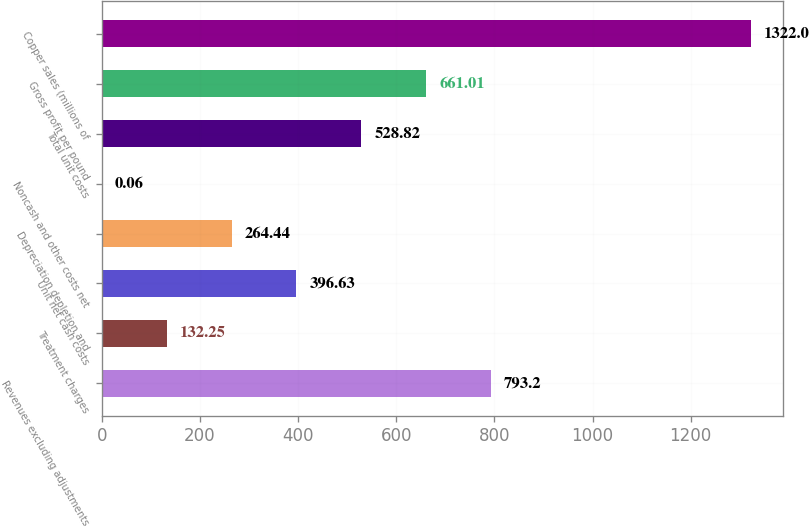Convert chart to OTSL. <chart><loc_0><loc_0><loc_500><loc_500><bar_chart><fcel>Revenues excluding adjustments<fcel>Treatment charges<fcel>Unit net cash costs<fcel>Depreciation depletion and<fcel>Noncash and other costs net<fcel>Total unit costs<fcel>Gross profit per pound<fcel>Copper sales (millions of<nl><fcel>793.2<fcel>132.25<fcel>396.63<fcel>264.44<fcel>0.06<fcel>528.82<fcel>661.01<fcel>1322<nl></chart> 